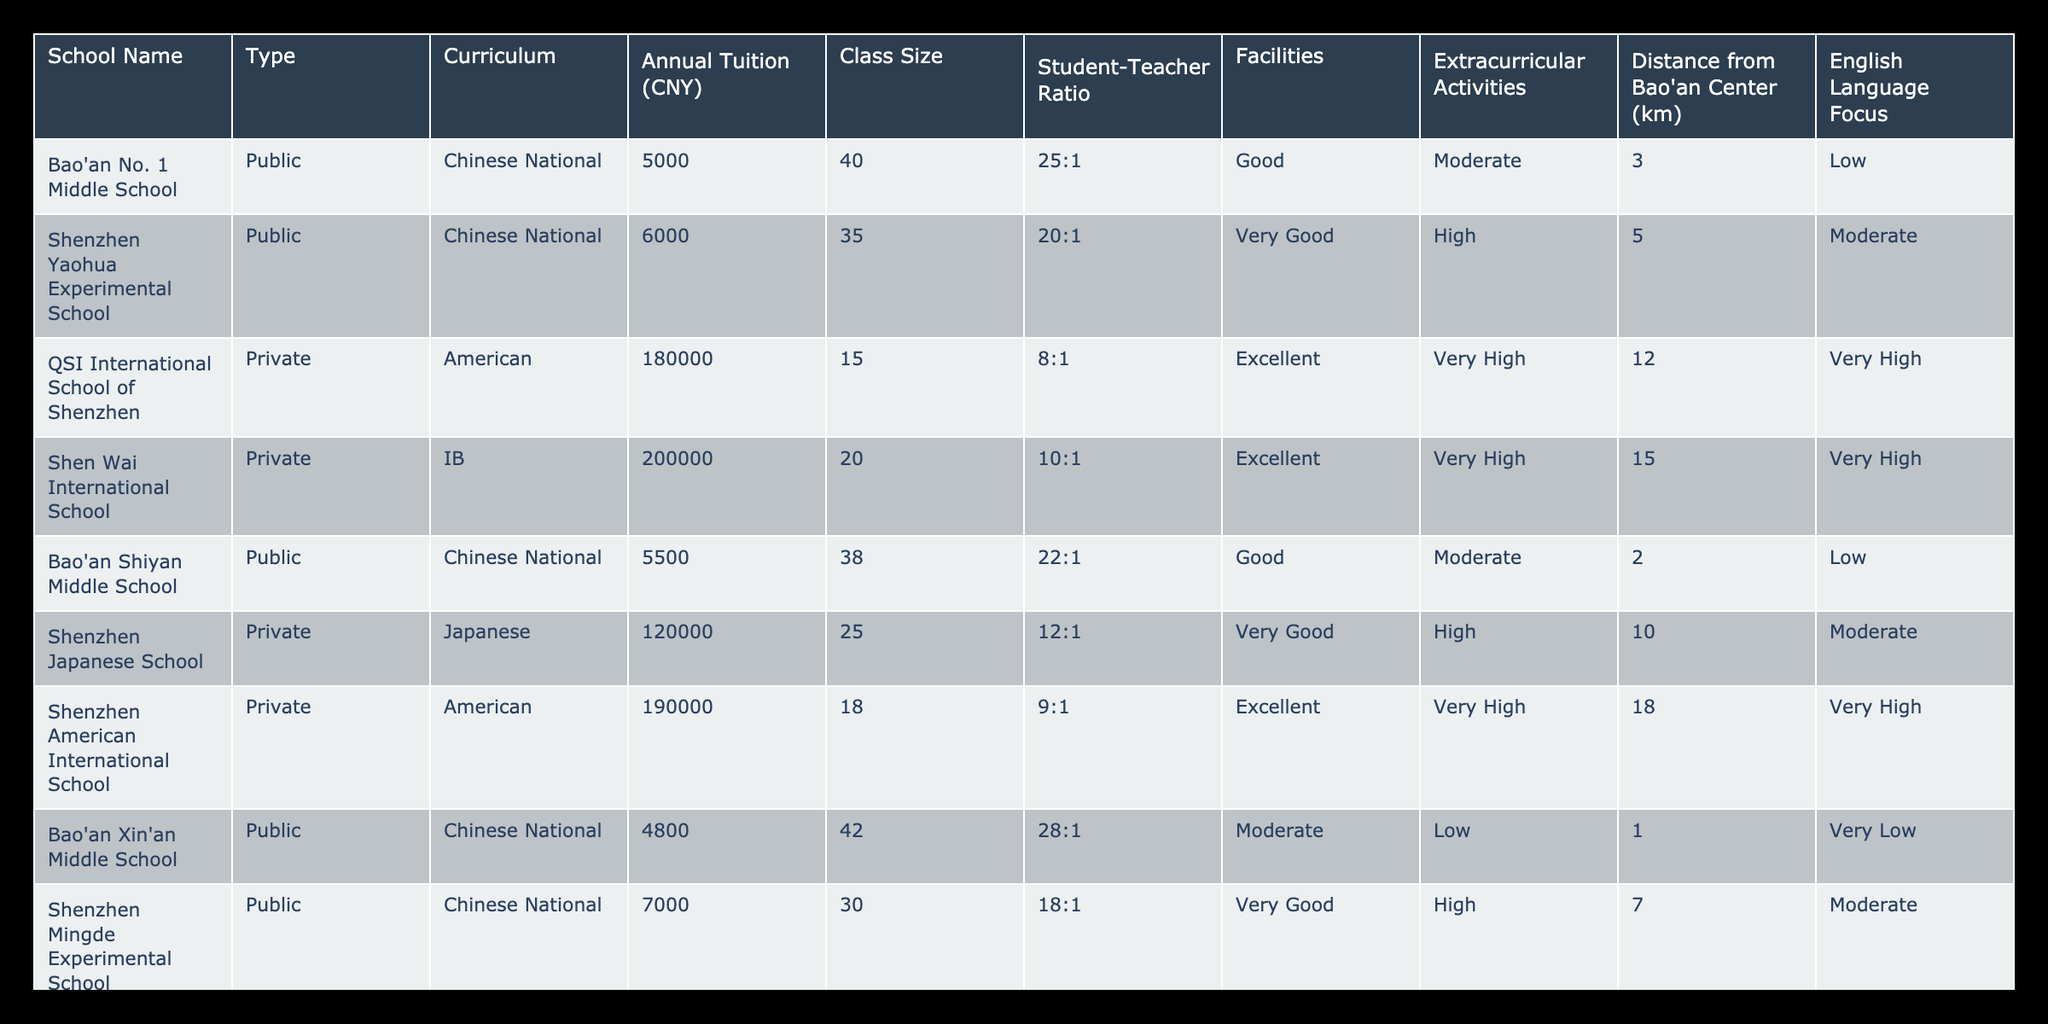What is the annual tuition of Shenzhen Yaohua Experimental School? The table lists the annual tuition for Shenzhen Yaohua Experimental School and the value is 6000 CNY.
Answer: 6000 CNY Which school has the highest student-teacher ratio? By examining the 'Student-Teacher Ratio' column, Bao'an Xin'an Middle School shows the highest ratio (28:1) compared to others.
Answer: Bao'an Xin'an Middle School What is the average annual tuition of public schools in Bao'an? The public schools listed are Bao'an No. 1 Middle School (5000 CNY), Shenzhen Yaohua Experimental School (6000 CNY), Bao'an Shiyan Middle School (5500 CNY), and Shenzhen Mingde Experimental School (7000 CNY). Adding these gives a total of 23500 CNY, and dividing by 4 (number of schools) gives an average of 5875 CNY.
Answer: 5875 CNY Is there a private school with a very high English language focus? Inspecting the 'English Language Focus' column, QSI International School of Shenzhen, Shen Wai International School, Shenzhen American International School, and Bromsgrove School Mission Hills are marked as 'Very High', indicating they do focus heavily on English.
Answer: Yes Which type of school has the lowest average class size, and what is that size? The class sizes for public schools are 40, 35, 38, 30, and for private schools are 15, 20, 25, 18, and 16. Calculating the average for public schools gives 34.0 (sum 143/4) and for private schools gives 19.5 (sum 74/4). Since 19.5 is lower, private schools have a smaller average class size.
Answer: Private schools, 19.5 students How many kilometers is Bao'an Xin'an Middle School from Bao'an Center? The distance from Bao'an Center for Bao'an Xin'an Middle School is explicitly listed as 1 km in the table.
Answer: 1 km Are there any public schools with excellent facilities? By reviewing the 'Facilities' column, Shenzhen Mingde Experimental School (Very Good) is the only public school that meets this criterion, indicating that there are no public schools labeled as excellent.
Answer: No What is the difference in annual tuition between the most expensive private school and the least expensive public school? The most expensive private school is Bromsgrove School Mission Hills (220000 CNY) and the least expensive public school is Bao'an Xin'an Middle School (4800 CNY). The difference is calculated as 220000 - 4800 = 215200 CNY.
Answer: 215200 CNY 